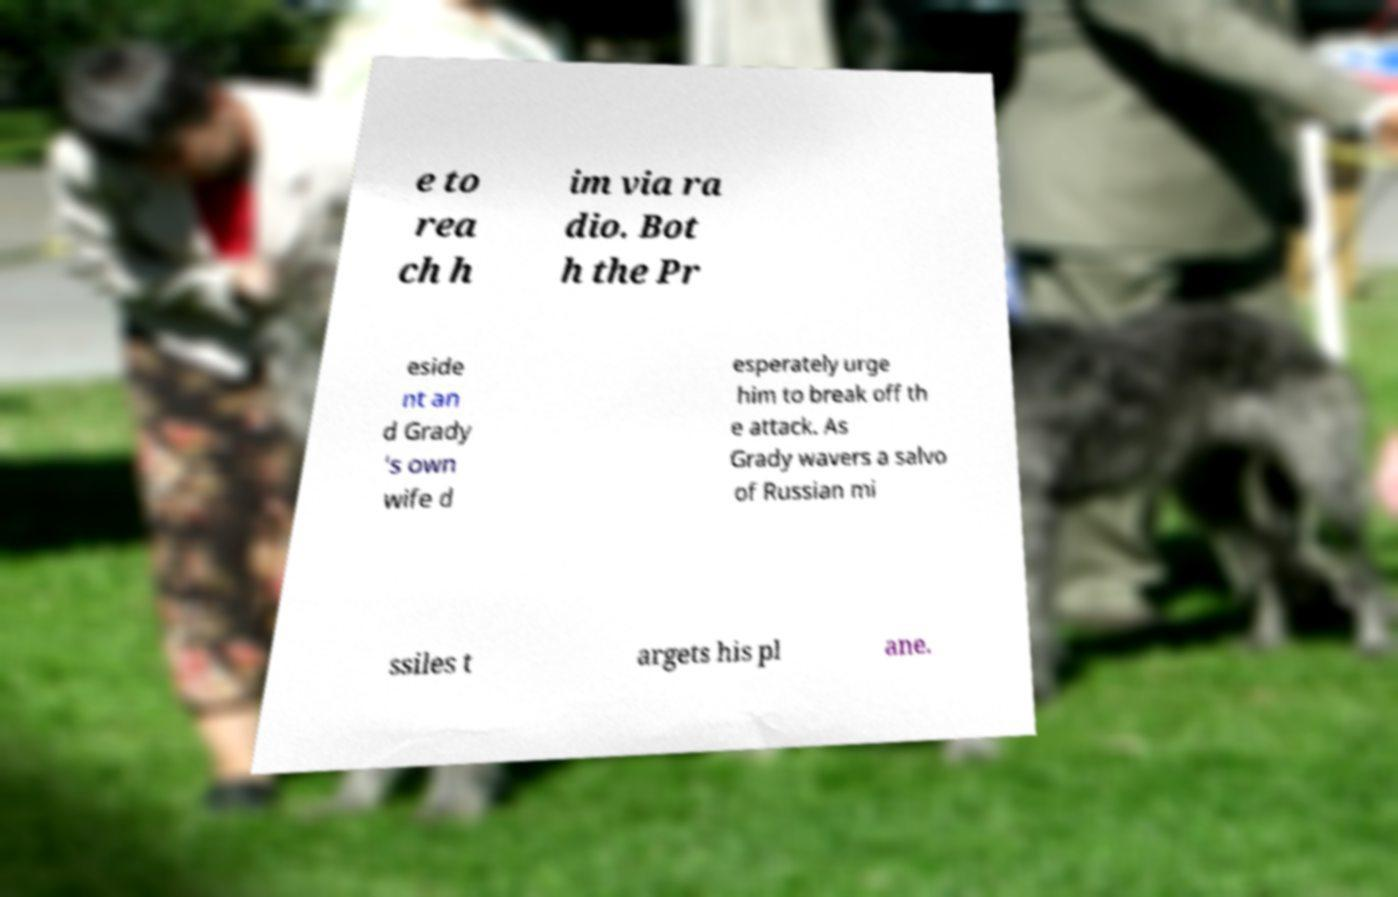Can you read and provide the text displayed in the image?This photo seems to have some interesting text. Can you extract and type it out for me? e to rea ch h im via ra dio. Bot h the Pr eside nt an d Grady 's own wife d esperately urge him to break off th e attack. As Grady wavers a salvo of Russian mi ssiles t argets his pl ane. 